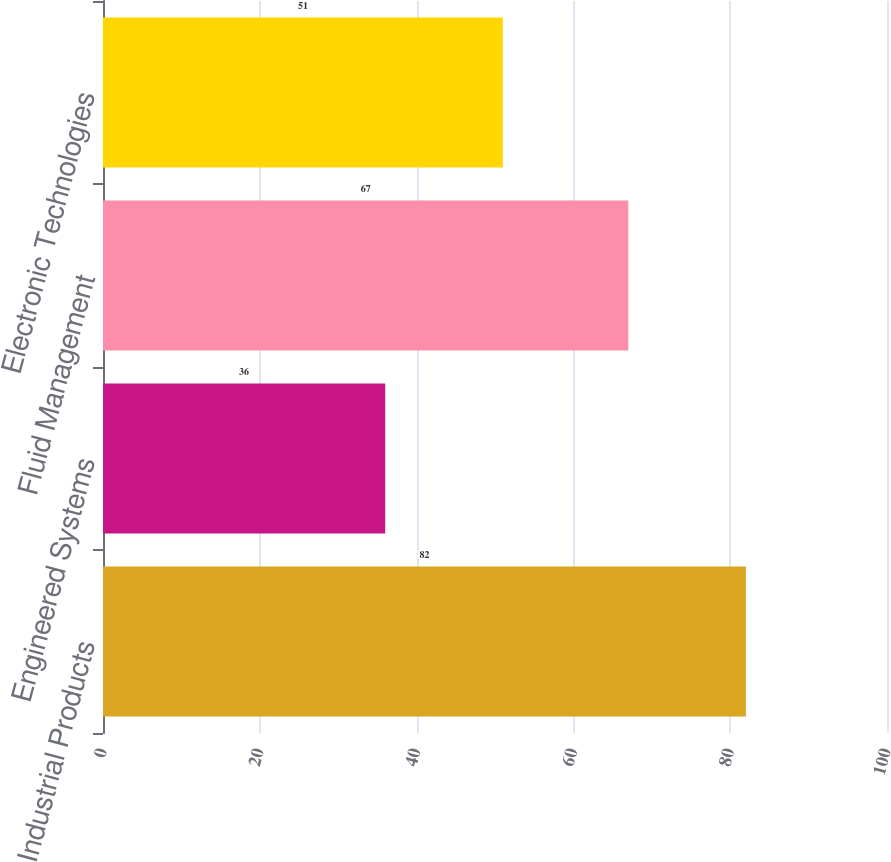Convert chart. <chart><loc_0><loc_0><loc_500><loc_500><bar_chart><fcel>Industrial Products<fcel>Engineered Systems<fcel>Fluid Management<fcel>Electronic Technologies<nl><fcel>82<fcel>36<fcel>67<fcel>51<nl></chart> 